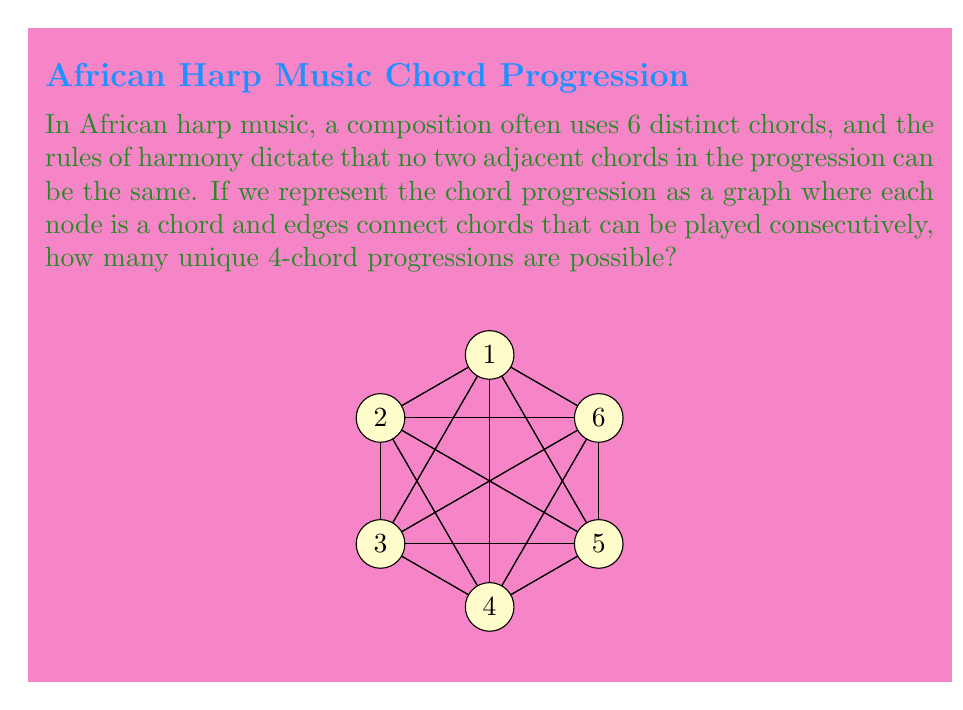Could you help me with this problem? Let's approach this step-by-step:

1) First, we need to understand what the graph represents. Each node is a chord, and edges connect chords that can be played consecutively. Since no two adjacent chords can be the same, there are no self-loops in the graph.

2) This problem is equivalent to counting the number of 4-vertex paths in a complete graph with 6 vertices (as any chord can follow any other chord except itself).

3) To count the number of 4-vertex paths:
   - We have 6 choices for the first chord.
   - For each subsequent chord, we have 5 choices (any chord except the one just played).

4) Therefore, the total number of 4-chord progressions is:

   $$6 \times 5 \times 5 \times 5 = 6 \times 5^3$$

5) Let's calculate this:
   $$6 \times 5^3 = 6 \times 125 = 750$$

Thus, there are 750 unique 4-chord progressions possible in this African harp composition.
Answer: 750 